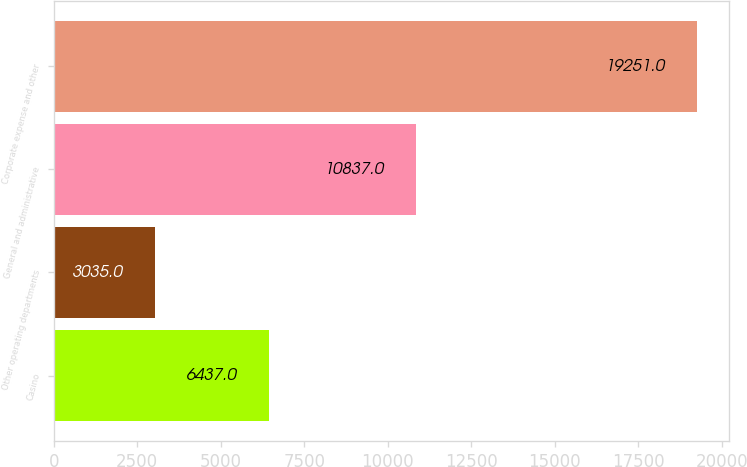<chart> <loc_0><loc_0><loc_500><loc_500><bar_chart><fcel>Casino<fcel>Other operating departments<fcel>General and administrative<fcel>Corporate expense and other<nl><fcel>6437<fcel>3035<fcel>10837<fcel>19251<nl></chart> 